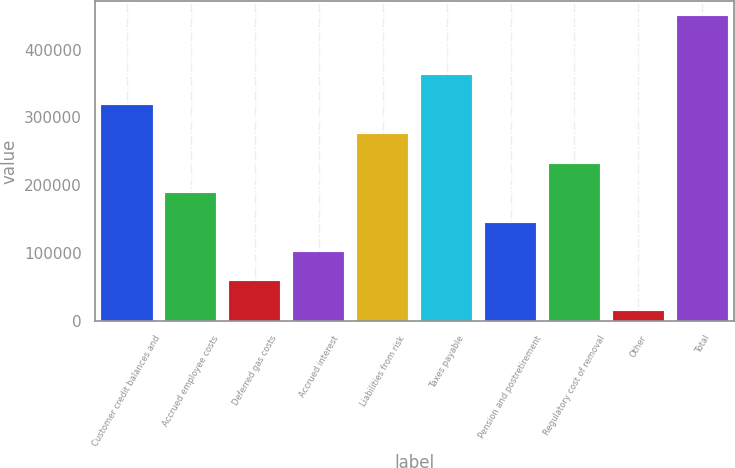Convert chart. <chart><loc_0><loc_0><loc_500><loc_500><bar_chart><fcel>Customer credit balances and<fcel>Accrued employee costs<fcel>Deferred gas costs<fcel>Accrued interest<fcel>Liabilities from risk<fcel>Taxes payable<fcel>Pension and postretirement<fcel>Regulatory cost of removal<fcel>Other<fcel>Total<nl><fcel>318706<fcel>188375<fcel>58044.5<fcel>101488<fcel>275262<fcel>362149<fcel>144932<fcel>231818<fcel>14601<fcel>449036<nl></chart> 